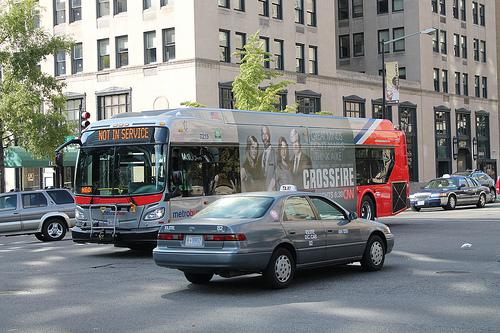Question: where is the word "crossfire"?
Choices:
A. On a marquee.
B. On the side of the bus.
C. On a billboard.
D. On a placard.
Answer with the letter. Answer: B Question: why do we know the bus is not going to pick up anyone?
Choices:
A. Because the driver is gone.
B. Because the tire is flat.
C. Because the front says, "not in service.".
D. Because the bus is already full.
Answer with the letter. Answer: C Question: what tells us the car by the bus is a cab?
Choices:
A. The yellow and black color.
B. The sign on the side.
C. The white lit sign.
D. The white item on the roof that says "taxi.".
Answer with the letter. Answer: D 